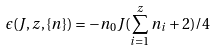<formula> <loc_0><loc_0><loc_500><loc_500>\epsilon ( { J } , z , \{ n \} ) = - n _ { 0 } { J } ( \sum _ { i = 1 } ^ { z } n _ { i } + 2 ) / 4</formula> 